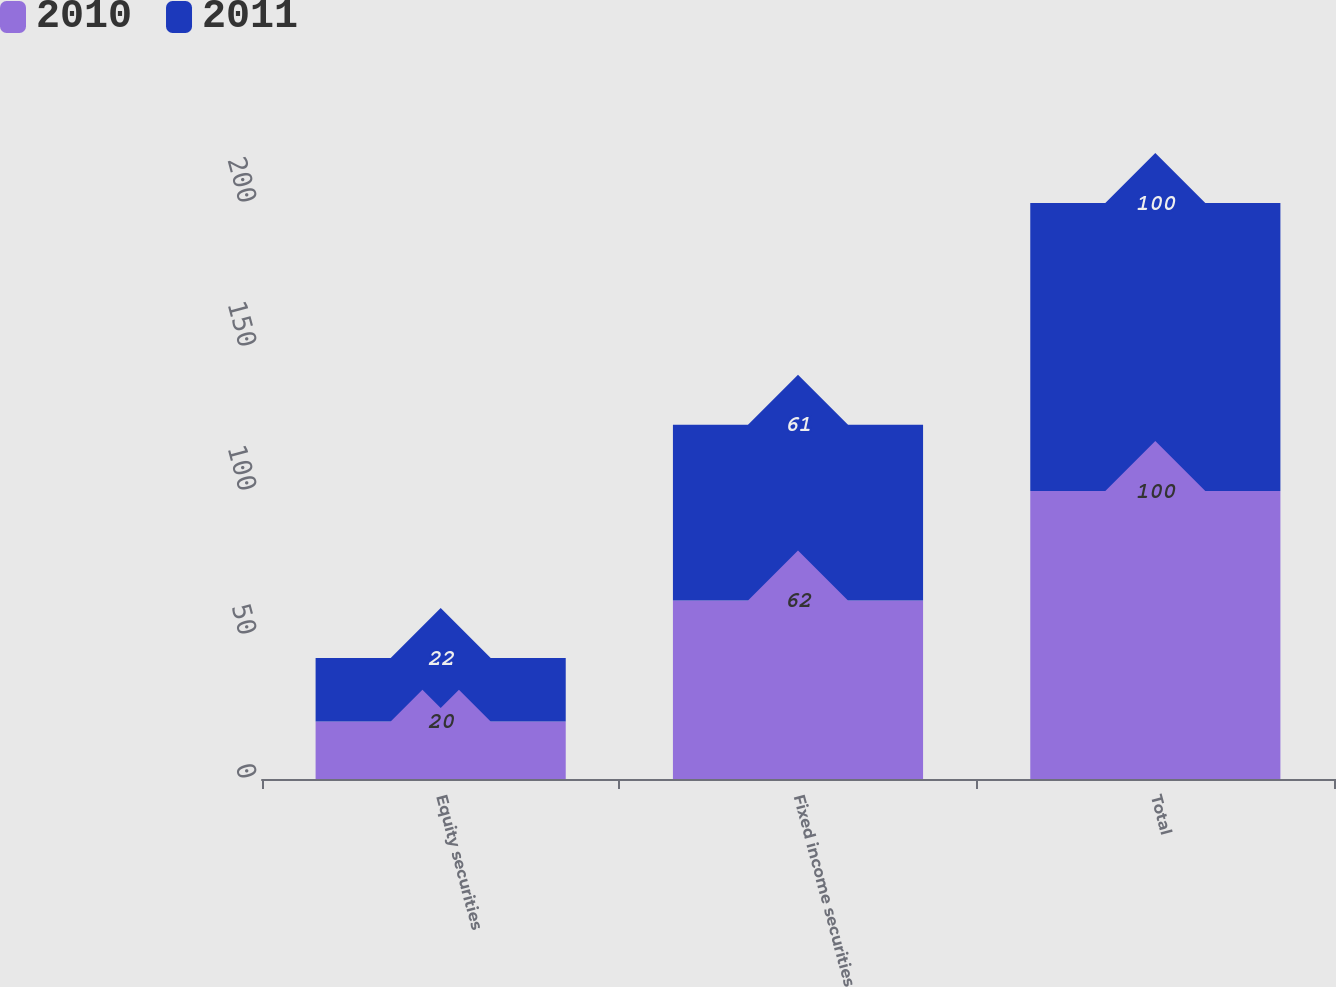Convert chart. <chart><loc_0><loc_0><loc_500><loc_500><stacked_bar_chart><ecel><fcel>Equity securities<fcel>Fixed income securities<fcel>Total<nl><fcel>2010<fcel>20<fcel>62<fcel>100<nl><fcel>2011<fcel>22<fcel>61<fcel>100<nl></chart> 